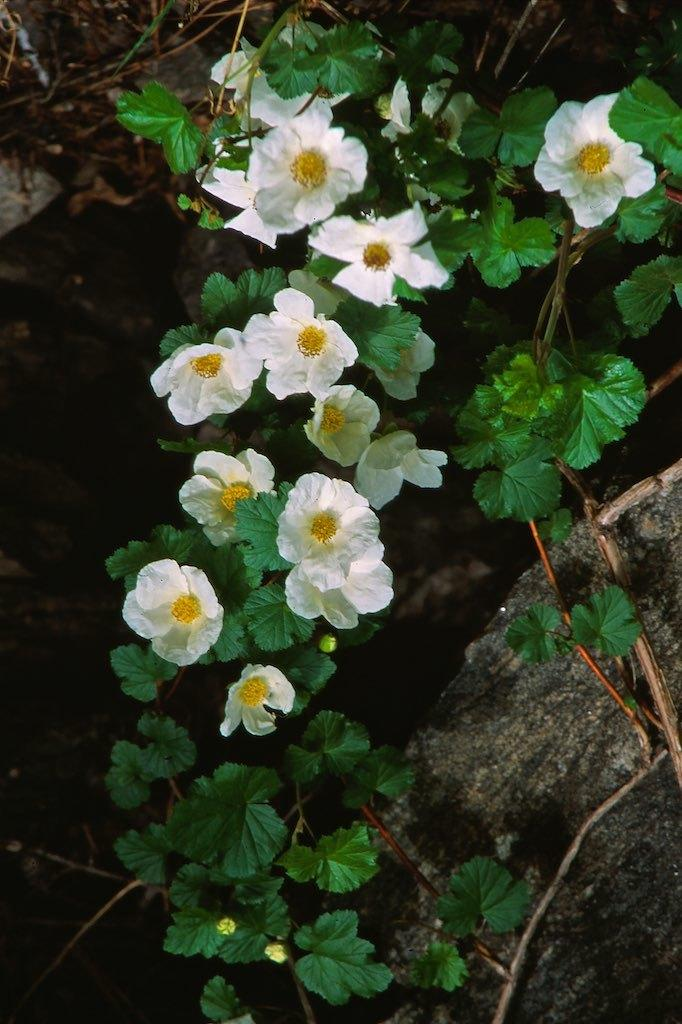What color are the flowers in the image? The flowers in the image are white. Where are the flowers located? The flowers are on a plant. How many babies are crawling on the dirt in the image? There are no babies or dirt present in the image; it features white color flowers on a plant. 